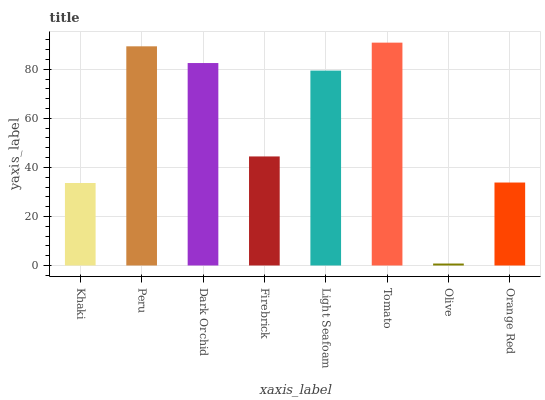Is Olive the minimum?
Answer yes or no. Yes. Is Tomato the maximum?
Answer yes or no. Yes. Is Peru the minimum?
Answer yes or no. No. Is Peru the maximum?
Answer yes or no. No. Is Peru greater than Khaki?
Answer yes or no. Yes. Is Khaki less than Peru?
Answer yes or no. Yes. Is Khaki greater than Peru?
Answer yes or no. No. Is Peru less than Khaki?
Answer yes or no. No. Is Light Seafoam the high median?
Answer yes or no. Yes. Is Firebrick the low median?
Answer yes or no. Yes. Is Orange Red the high median?
Answer yes or no. No. Is Khaki the low median?
Answer yes or no. No. 